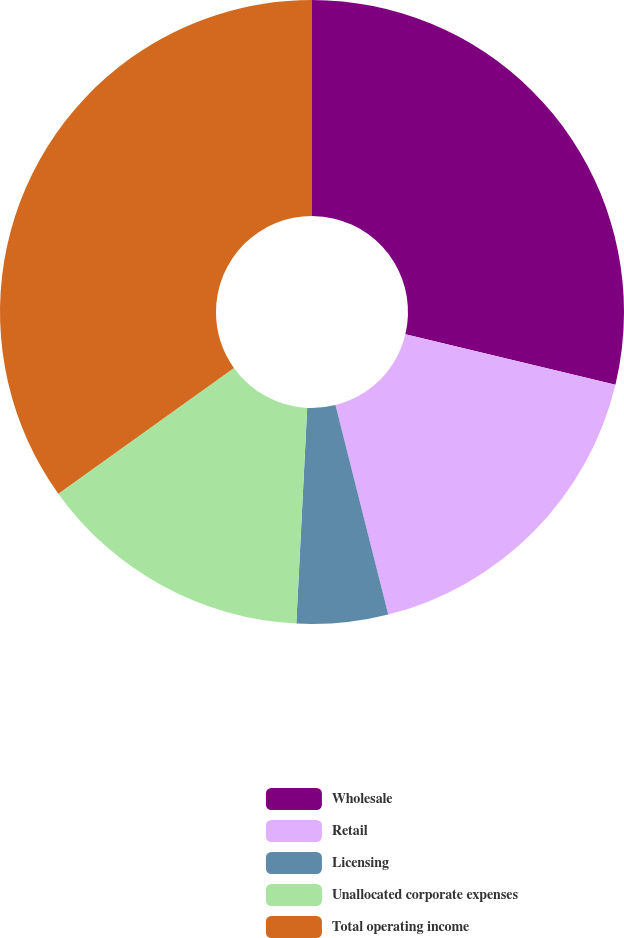<chart> <loc_0><loc_0><loc_500><loc_500><pie_chart><fcel>Wholesale<fcel>Retail<fcel>Licensing<fcel>Unallocated corporate expenses<fcel>Total operating income<nl><fcel>28.74%<fcel>17.33%<fcel>4.73%<fcel>14.31%<fcel>34.89%<nl></chart> 